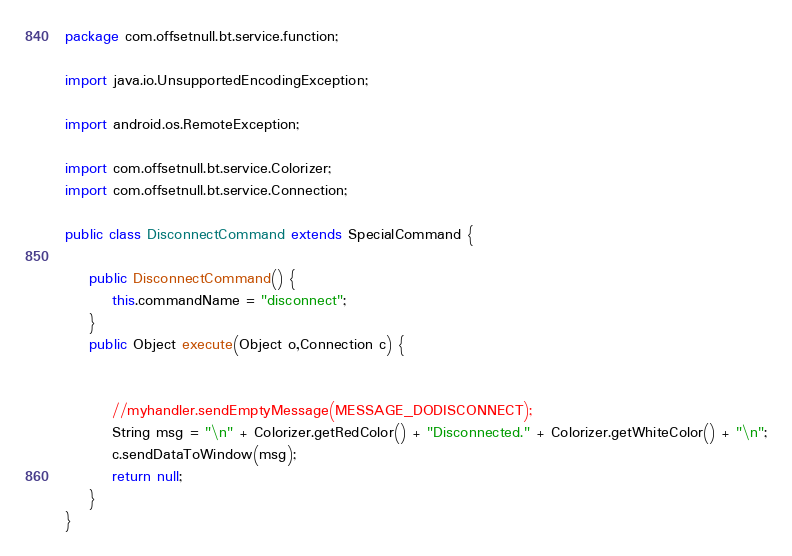Convert code to text. <code><loc_0><loc_0><loc_500><loc_500><_Java_>package com.offsetnull.bt.service.function;

import java.io.UnsupportedEncodingException;

import android.os.RemoteException;

import com.offsetnull.bt.service.Colorizer;
import com.offsetnull.bt.service.Connection;

public class DisconnectCommand extends SpecialCommand {
	
	public DisconnectCommand() {
		this.commandName = "disconnect";
	}
	public Object execute(Object o,Connection c) {
		
		
		//myhandler.sendEmptyMessage(MESSAGE_DODISCONNECT);
		String msg = "\n" + Colorizer.getRedColor() + "Disconnected." + Colorizer.getWhiteColor() + "\n";
		c.sendDataToWindow(msg);
		return null;
	}
}
</code> 